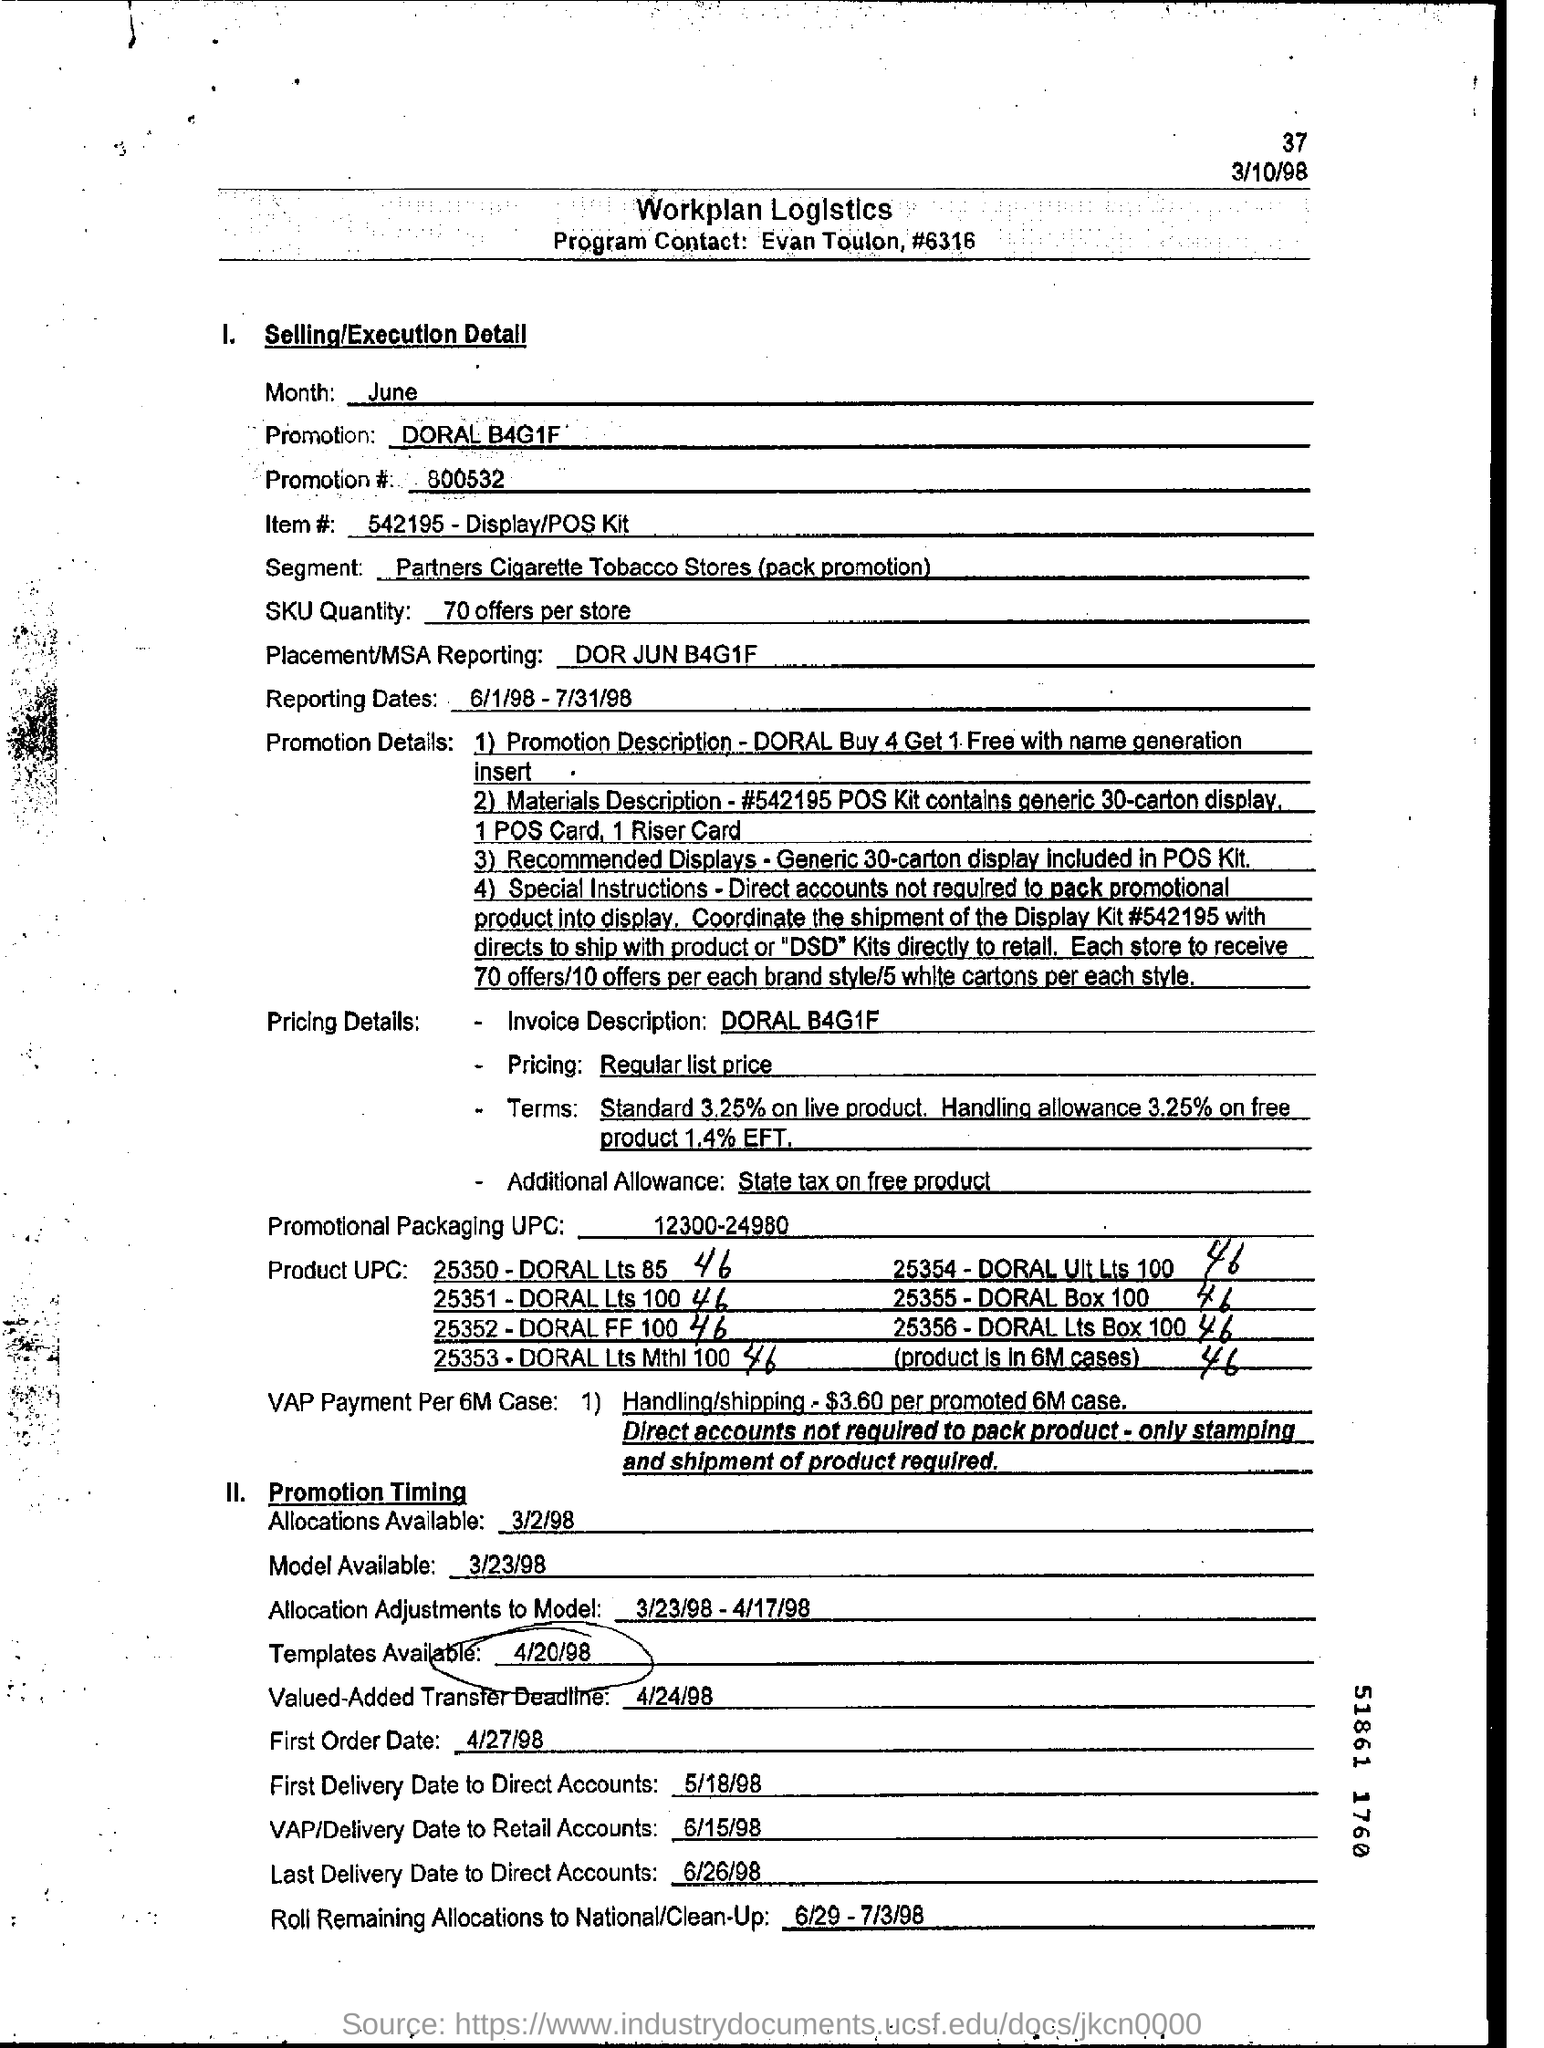Point out several critical features in this image. What is the promotion number, 800532...? The invoice description is "DORAL B4G1F". The promotion being offered is the Doral B4G1F deal, where customers can purchase a unit at 40% off the original price, and receive a further 10% off if they pay in full within one month. The reporting period for the given dates is from June 1, 1998, to July 31, 1998. The Program Contact is Evan Toulon. 